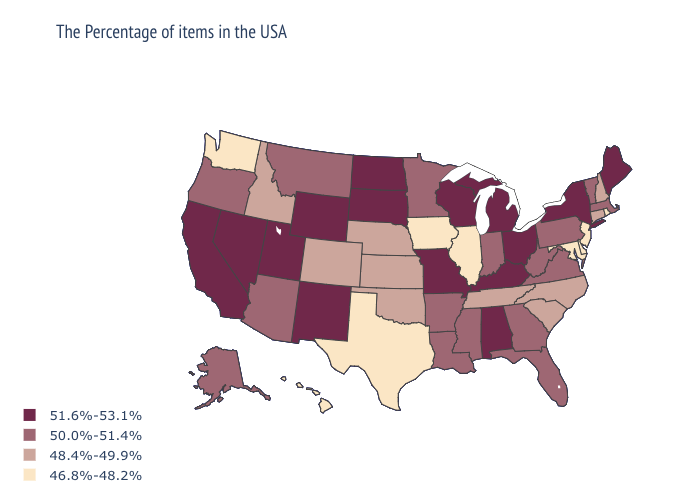Which states have the highest value in the USA?
Write a very short answer. Maine, New York, Ohio, Michigan, Kentucky, Alabama, Wisconsin, Missouri, South Dakota, North Dakota, Wyoming, New Mexico, Utah, Nevada, California. Name the states that have a value in the range 48.4%-49.9%?
Keep it brief. New Hampshire, Connecticut, North Carolina, South Carolina, Tennessee, Kansas, Nebraska, Oklahoma, Colorado, Idaho. Does New Hampshire have the lowest value in the USA?
Keep it brief. No. What is the value of Connecticut?
Give a very brief answer. 48.4%-49.9%. Name the states that have a value in the range 46.8%-48.2%?
Concise answer only. Rhode Island, New Jersey, Delaware, Maryland, Illinois, Iowa, Texas, Washington, Hawaii. Does Idaho have the lowest value in the West?
Quick response, please. No. Among the states that border Illinois , which have the lowest value?
Keep it brief. Iowa. What is the value of Oregon?
Write a very short answer. 50.0%-51.4%. Does New York have the highest value in the USA?
Be succinct. Yes. What is the value of North Carolina?
Short answer required. 48.4%-49.9%. Name the states that have a value in the range 50.0%-51.4%?
Write a very short answer. Massachusetts, Vermont, Pennsylvania, Virginia, West Virginia, Florida, Georgia, Indiana, Mississippi, Louisiana, Arkansas, Minnesota, Montana, Arizona, Oregon, Alaska. Name the states that have a value in the range 46.8%-48.2%?
Give a very brief answer. Rhode Island, New Jersey, Delaware, Maryland, Illinois, Iowa, Texas, Washington, Hawaii. What is the value of Alabama?
Concise answer only. 51.6%-53.1%. 